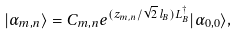<formula> <loc_0><loc_0><loc_500><loc_500>| \alpha _ { m , n } \rangle = C _ { m , n } e ^ { ( z _ { m , n } / \sqrt { 2 } \, l _ { B } ) L _ { B } ^ { \dag } } | \alpha _ { 0 , 0 } \rangle ,</formula> 